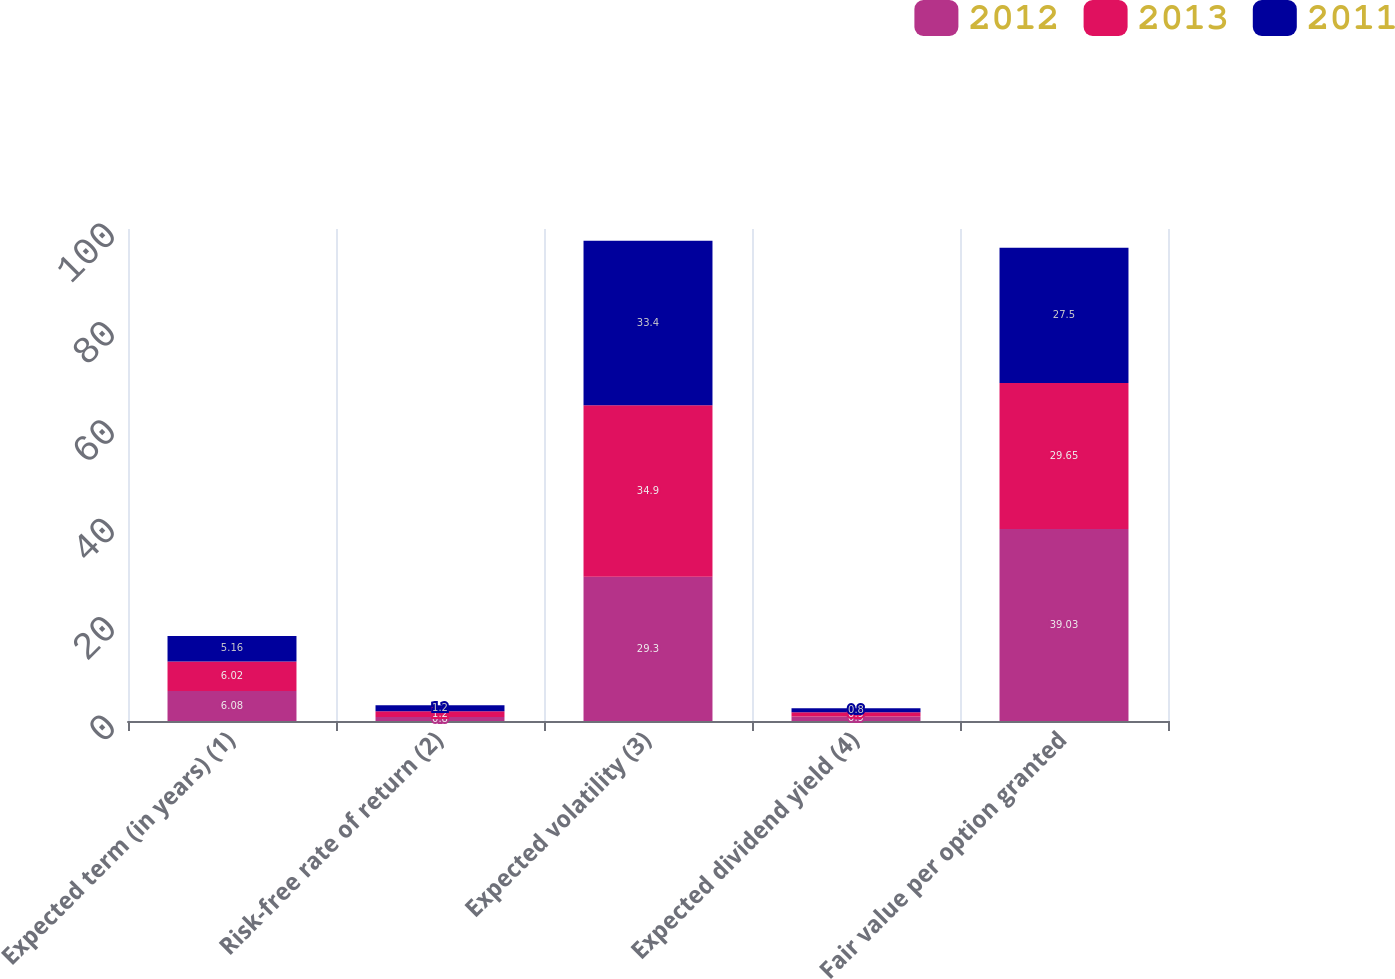<chart> <loc_0><loc_0><loc_500><loc_500><stacked_bar_chart><ecel><fcel>Expected term (in years) (1)<fcel>Risk-free rate of return (2)<fcel>Expected volatility (3)<fcel>Expected dividend yield (4)<fcel>Fair value per option granted<nl><fcel>2012<fcel>6.08<fcel>0.8<fcel>29.3<fcel>0.9<fcel>39.03<nl><fcel>2013<fcel>6.02<fcel>1.2<fcel>34.9<fcel>0.9<fcel>29.65<nl><fcel>2011<fcel>5.16<fcel>1.2<fcel>33.4<fcel>0.8<fcel>27.5<nl></chart> 